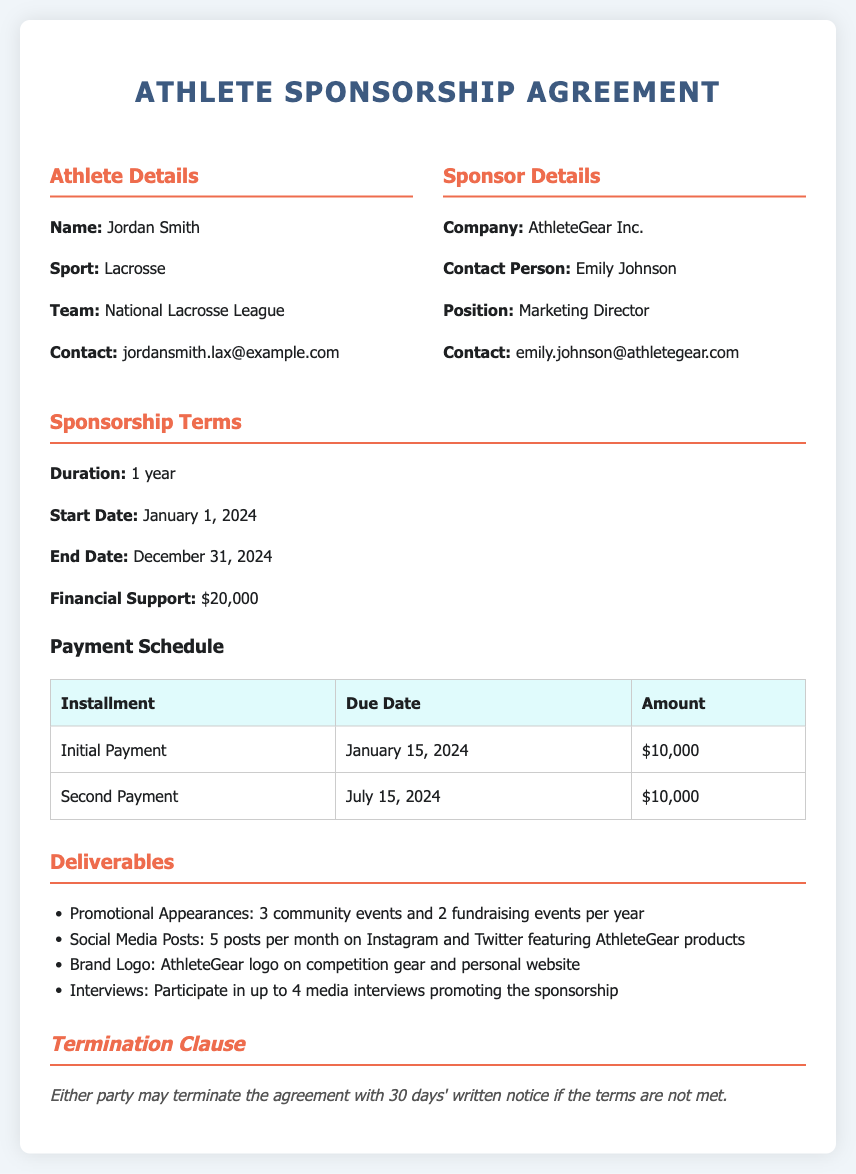What is the athlete's name? The athlete's name is stated clearly in the document under "Athlete Details."
Answer: Jordan Smith What is the total financial support provided by the sponsor? The document specifies the total financial support amount under "Financial Support."
Answer: $20,000 What is the duration of the sponsorship agreement? The duration is mentioned in the section titled "Sponsorship Terms."
Answer: 1 year When is the second payment due? The due date for the second payment is listed in the "Payment Schedule" table.
Answer: July 15, 2024 How many social media posts are required each month? The number of required posts is indicated under "Deliverables."
Answer: 5 posts per month What is the termination notice period stated in the agreement? The notice period for termination is included in the "Termination Clause."
Answer: 30 days Which company is sponsoring the athlete? The sponsoring company is noted under "Sponsor Details."
Answer: AthleteGear Inc How many media interviews is the athlete expected to participate in? This number is specified in the "Deliverables" section regarding interviews.
Answer: 4 media interviews What is the start date of the sponsorship? The start date is mentioned in the "Sponsorship Terms."
Answer: January 1, 2024 